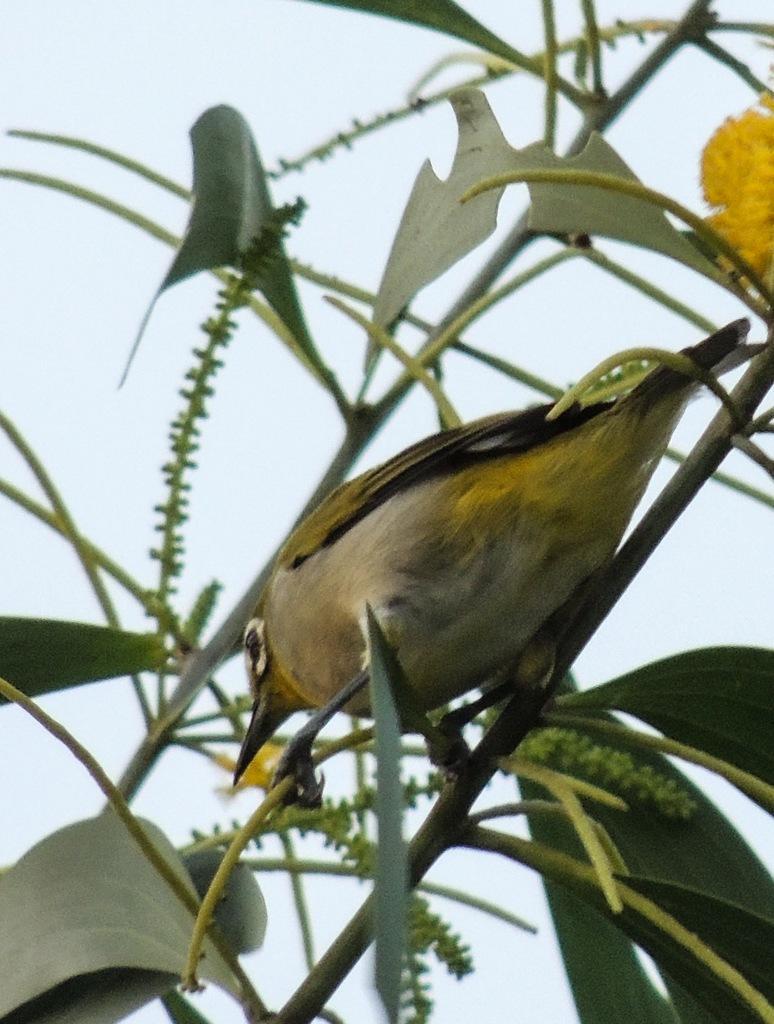Describe this image in one or two sentences. In the picture we can see a plant with some leaves and a bird sitting on the stem and in the background we can see a sky. 